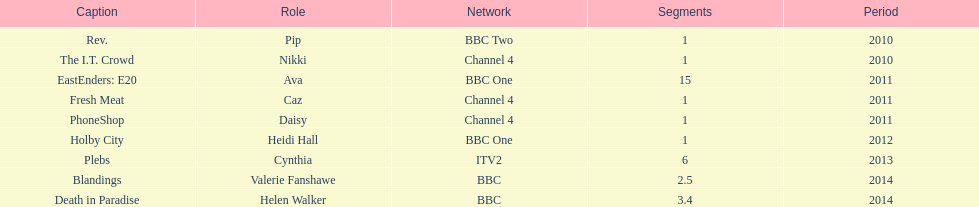What is the only role she played with broadcaster itv2? Cynthia. 